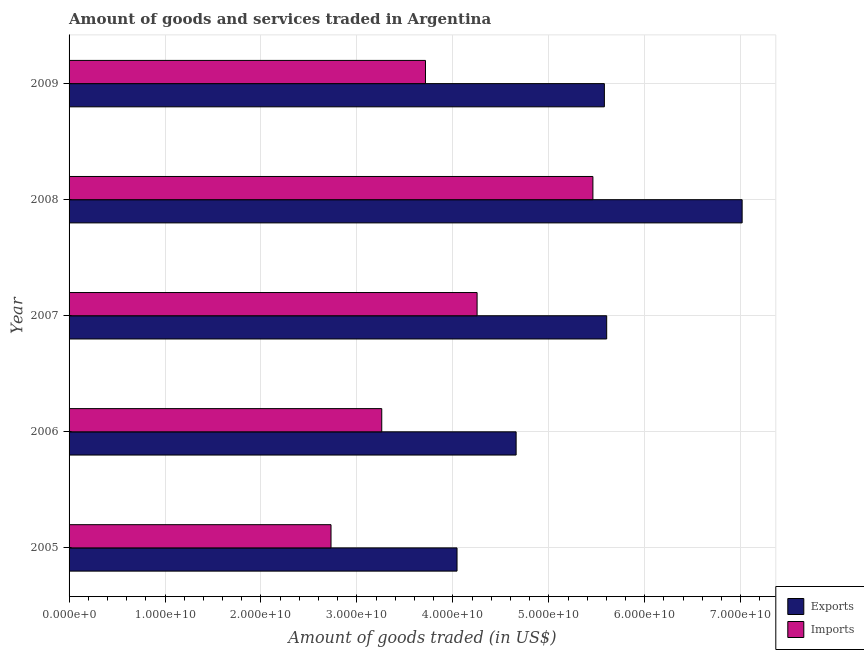Are the number of bars on each tick of the Y-axis equal?
Make the answer very short. Yes. How many bars are there on the 3rd tick from the bottom?
Offer a very short reply. 2. What is the amount of goods imported in 2005?
Make the answer very short. 2.73e+1. Across all years, what is the maximum amount of goods imported?
Provide a short and direct response. 5.46e+1. Across all years, what is the minimum amount of goods imported?
Offer a very short reply. 2.73e+1. In which year was the amount of goods imported maximum?
Provide a short and direct response. 2008. What is the total amount of goods imported in the graph?
Offer a very short reply. 1.94e+11. What is the difference between the amount of goods exported in 2005 and that in 2007?
Provide a short and direct response. -1.56e+1. What is the difference between the amount of goods imported in 2007 and the amount of goods exported in 2005?
Ensure brevity in your answer.  2.09e+09. What is the average amount of goods imported per year?
Your answer should be very brief. 3.88e+1. In the year 2007, what is the difference between the amount of goods imported and amount of goods exported?
Provide a short and direct response. -1.35e+1. What is the ratio of the amount of goods imported in 2005 to that in 2007?
Give a very brief answer. 0.64. Is the difference between the amount of goods exported in 2006 and 2007 greater than the difference between the amount of goods imported in 2006 and 2007?
Your answer should be compact. Yes. What is the difference between the highest and the second highest amount of goods imported?
Provide a short and direct response. 1.21e+1. What is the difference between the highest and the lowest amount of goods imported?
Provide a short and direct response. 2.73e+1. In how many years, is the amount of goods imported greater than the average amount of goods imported taken over all years?
Give a very brief answer. 2. Is the sum of the amount of goods imported in 2005 and 2006 greater than the maximum amount of goods exported across all years?
Provide a short and direct response. No. What does the 1st bar from the top in 2005 represents?
Keep it short and to the point. Imports. What does the 1st bar from the bottom in 2005 represents?
Keep it short and to the point. Exports. Are all the bars in the graph horizontal?
Keep it short and to the point. Yes. How many years are there in the graph?
Keep it short and to the point. 5. Does the graph contain grids?
Offer a terse response. Yes. Where does the legend appear in the graph?
Your answer should be very brief. Bottom right. What is the title of the graph?
Ensure brevity in your answer.  Amount of goods and services traded in Argentina. Does "Age 65(female)" appear as one of the legend labels in the graph?
Make the answer very short. No. What is the label or title of the X-axis?
Offer a terse response. Amount of goods traded (in US$). What is the Amount of goods traded (in US$) of Exports in 2005?
Make the answer very short. 4.04e+1. What is the Amount of goods traded (in US$) in Imports in 2005?
Ensure brevity in your answer.  2.73e+1. What is the Amount of goods traded (in US$) in Exports in 2006?
Provide a succinct answer. 4.66e+1. What is the Amount of goods traded (in US$) of Imports in 2006?
Offer a terse response. 3.26e+1. What is the Amount of goods traded (in US$) in Exports in 2007?
Your response must be concise. 5.60e+1. What is the Amount of goods traded (in US$) of Imports in 2007?
Ensure brevity in your answer.  4.25e+1. What is the Amount of goods traded (in US$) in Exports in 2008?
Your answer should be very brief. 7.01e+1. What is the Amount of goods traded (in US$) of Imports in 2008?
Offer a very short reply. 5.46e+1. What is the Amount of goods traded (in US$) of Exports in 2009?
Ensure brevity in your answer.  5.58e+1. What is the Amount of goods traded (in US$) in Imports in 2009?
Make the answer very short. 3.71e+1. Across all years, what is the maximum Amount of goods traded (in US$) of Exports?
Offer a very short reply. 7.01e+1. Across all years, what is the maximum Amount of goods traded (in US$) of Imports?
Your answer should be compact. 5.46e+1. Across all years, what is the minimum Amount of goods traded (in US$) in Exports?
Offer a terse response. 4.04e+1. Across all years, what is the minimum Amount of goods traded (in US$) in Imports?
Give a very brief answer. 2.73e+1. What is the total Amount of goods traded (in US$) of Exports in the graph?
Offer a very short reply. 2.69e+11. What is the total Amount of goods traded (in US$) of Imports in the graph?
Give a very brief answer. 1.94e+11. What is the difference between the Amount of goods traded (in US$) in Exports in 2005 and that in 2006?
Keep it short and to the point. -6.16e+09. What is the difference between the Amount of goods traded (in US$) in Imports in 2005 and that in 2006?
Offer a very short reply. -5.29e+09. What is the difference between the Amount of goods traded (in US$) of Exports in 2005 and that in 2007?
Offer a terse response. -1.56e+1. What is the difference between the Amount of goods traded (in US$) in Imports in 2005 and that in 2007?
Offer a very short reply. -1.52e+1. What is the difference between the Amount of goods traded (in US$) of Exports in 2005 and that in 2008?
Offer a terse response. -2.97e+1. What is the difference between the Amount of goods traded (in US$) in Imports in 2005 and that in 2008?
Keep it short and to the point. -2.73e+1. What is the difference between the Amount of goods traded (in US$) in Exports in 2005 and that in 2009?
Keep it short and to the point. -1.54e+1. What is the difference between the Amount of goods traded (in US$) in Imports in 2005 and that in 2009?
Make the answer very short. -9.85e+09. What is the difference between the Amount of goods traded (in US$) in Exports in 2006 and that in 2007?
Keep it short and to the point. -9.44e+09. What is the difference between the Amount of goods traded (in US$) of Imports in 2006 and that in 2007?
Make the answer very short. -9.94e+09. What is the difference between the Amount of goods traded (in US$) of Exports in 2006 and that in 2008?
Make the answer very short. -2.36e+1. What is the difference between the Amount of goods traded (in US$) in Imports in 2006 and that in 2008?
Offer a terse response. -2.20e+1. What is the difference between the Amount of goods traded (in US$) of Exports in 2006 and that in 2009?
Your answer should be very brief. -9.20e+09. What is the difference between the Amount of goods traded (in US$) of Imports in 2006 and that in 2009?
Offer a very short reply. -4.56e+09. What is the difference between the Amount of goods traded (in US$) of Exports in 2007 and that in 2008?
Your response must be concise. -1.41e+1. What is the difference between the Amount of goods traded (in US$) in Imports in 2007 and that in 2008?
Your answer should be very brief. -1.21e+1. What is the difference between the Amount of goods traded (in US$) in Exports in 2007 and that in 2009?
Your response must be concise. 2.42e+08. What is the difference between the Amount of goods traded (in US$) in Imports in 2007 and that in 2009?
Make the answer very short. 5.38e+09. What is the difference between the Amount of goods traded (in US$) of Exports in 2008 and that in 2009?
Your answer should be very brief. 1.44e+1. What is the difference between the Amount of goods traded (in US$) of Imports in 2008 and that in 2009?
Offer a terse response. 1.75e+1. What is the difference between the Amount of goods traded (in US$) in Exports in 2005 and the Amount of goods traded (in US$) in Imports in 2006?
Offer a terse response. 7.85e+09. What is the difference between the Amount of goods traded (in US$) of Exports in 2005 and the Amount of goods traded (in US$) of Imports in 2007?
Your response must be concise. -2.09e+09. What is the difference between the Amount of goods traded (in US$) of Exports in 2005 and the Amount of goods traded (in US$) of Imports in 2008?
Provide a short and direct response. -1.42e+1. What is the difference between the Amount of goods traded (in US$) in Exports in 2005 and the Amount of goods traded (in US$) in Imports in 2009?
Provide a short and direct response. 3.29e+09. What is the difference between the Amount of goods traded (in US$) in Exports in 2006 and the Amount of goods traded (in US$) in Imports in 2007?
Provide a succinct answer. 4.07e+09. What is the difference between the Amount of goods traded (in US$) of Exports in 2006 and the Amount of goods traded (in US$) of Imports in 2008?
Give a very brief answer. -8.00e+09. What is the difference between the Amount of goods traded (in US$) in Exports in 2006 and the Amount of goods traded (in US$) in Imports in 2009?
Ensure brevity in your answer.  9.45e+09. What is the difference between the Amount of goods traded (in US$) of Exports in 2007 and the Amount of goods traded (in US$) of Imports in 2008?
Provide a succinct answer. 1.44e+09. What is the difference between the Amount of goods traded (in US$) of Exports in 2007 and the Amount of goods traded (in US$) of Imports in 2009?
Keep it short and to the point. 1.89e+1. What is the difference between the Amount of goods traded (in US$) of Exports in 2008 and the Amount of goods traded (in US$) of Imports in 2009?
Provide a short and direct response. 3.30e+1. What is the average Amount of goods traded (in US$) in Exports per year?
Make the answer very short. 5.38e+1. What is the average Amount of goods traded (in US$) in Imports per year?
Give a very brief answer. 3.88e+1. In the year 2005, what is the difference between the Amount of goods traded (in US$) in Exports and Amount of goods traded (in US$) in Imports?
Offer a terse response. 1.31e+1. In the year 2006, what is the difference between the Amount of goods traded (in US$) of Exports and Amount of goods traded (in US$) of Imports?
Offer a very short reply. 1.40e+1. In the year 2007, what is the difference between the Amount of goods traded (in US$) of Exports and Amount of goods traded (in US$) of Imports?
Give a very brief answer. 1.35e+1. In the year 2008, what is the difference between the Amount of goods traded (in US$) of Exports and Amount of goods traded (in US$) of Imports?
Make the answer very short. 1.56e+1. In the year 2009, what is the difference between the Amount of goods traded (in US$) of Exports and Amount of goods traded (in US$) of Imports?
Offer a terse response. 1.86e+1. What is the ratio of the Amount of goods traded (in US$) of Exports in 2005 to that in 2006?
Offer a terse response. 0.87. What is the ratio of the Amount of goods traded (in US$) in Imports in 2005 to that in 2006?
Provide a succinct answer. 0.84. What is the ratio of the Amount of goods traded (in US$) in Exports in 2005 to that in 2007?
Offer a very short reply. 0.72. What is the ratio of the Amount of goods traded (in US$) of Imports in 2005 to that in 2007?
Your answer should be very brief. 0.64. What is the ratio of the Amount of goods traded (in US$) in Exports in 2005 to that in 2008?
Offer a terse response. 0.58. What is the ratio of the Amount of goods traded (in US$) of Exports in 2005 to that in 2009?
Provide a succinct answer. 0.72. What is the ratio of the Amount of goods traded (in US$) of Imports in 2005 to that in 2009?
Offer a very short reply. 0.73. What is the ratio of the Amount of goods traded (in US$) in Exports in 2006 to that in 2007?
Provide a succinct answer. 0.83. What is the ratio of the Amount of goods traded (in US$) in Imports in 2006 to that in 2007?
Your answer should be compact. 0.77. What is the ratio of the Amount of goods traded (in US$) of Exports in 2006 to that in 2008?
Ensure brevity in your answer.  0.66. What is the ratio of the Amount of goods traded (in US$) in Imports in 2006 to that in 2008?
Your response must be concise. 0.6. What is the ratio of the Amount of goods traded (in US$) in Exports in 2006 to that in 2009?
Your response must be concise. 0.84. What is the ratio of the Amount of goods traded (in US$) of Imports in 2006 to that in 2009?
Offer a terse response. 0.88. What is the ratio of the Amount of goods traded (in US$) of Exports in 2007 to that in 2008?
Keep it short and to the point. 0.8. What is the ratio of the Amount of goods traded (in US$) of Imports in 2007 to that in 2008?
Your response must be concise. 0.78. What is the ratio of the Amount of goods traded (in US$) of Exports in 2007 to that in 2009?
Keep it short and to the point. 1. What is the ratio of the Amount of goods traded (in US$) of Imports in 2007 to that in 2009?
Give a very brief answer. 1.14. What is the ratio of the Amount of goods traded (in US$) of Exports in 2008 to that in 2009?
Your response must be concise. 1.26. What is the ratio of the Amount of goods traded (in US$) of Imports in 2008 to that in 2009?
Provide a succinct answer. 1.47. What is the difference between the highest and the second highest Amount of goods traded (in US$) in Exports?
Your answer should be compact. 1.41e+1. What is the difference between the highest and the second highest Amount of goods traded (in US$) in Imports?
Provide a short and direct response. 1.21e+1. What is the difference between the highest and the lowest Amount of goods traded (in US$) of Exports?
Your answer should be very brief. 2.97e+1. What is the difference between the highest and the lowest Amount of goods traded (in US$) in Imports?
Ensure brevity in your answer.  2.73e+1. 